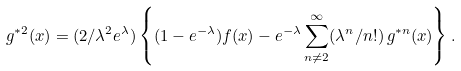Convert formula to latex. <formula><loc_0><loc_0><loc_500><loc_500>g ^ { \ast 2 } ( x ) = ( 2 / \lambda ^ { 2 } e ^ { \lambda } ) \left \{ ( 1 - e ^ { - \lambda } ) f ( x ) - e ^ { - \lambda } \sum _ { n \neq 2 } ^ { \infty } ( \lambda ^ { n } / n ! ) \, g ^ { \ast n } ( x ) \right \} .</formula> 